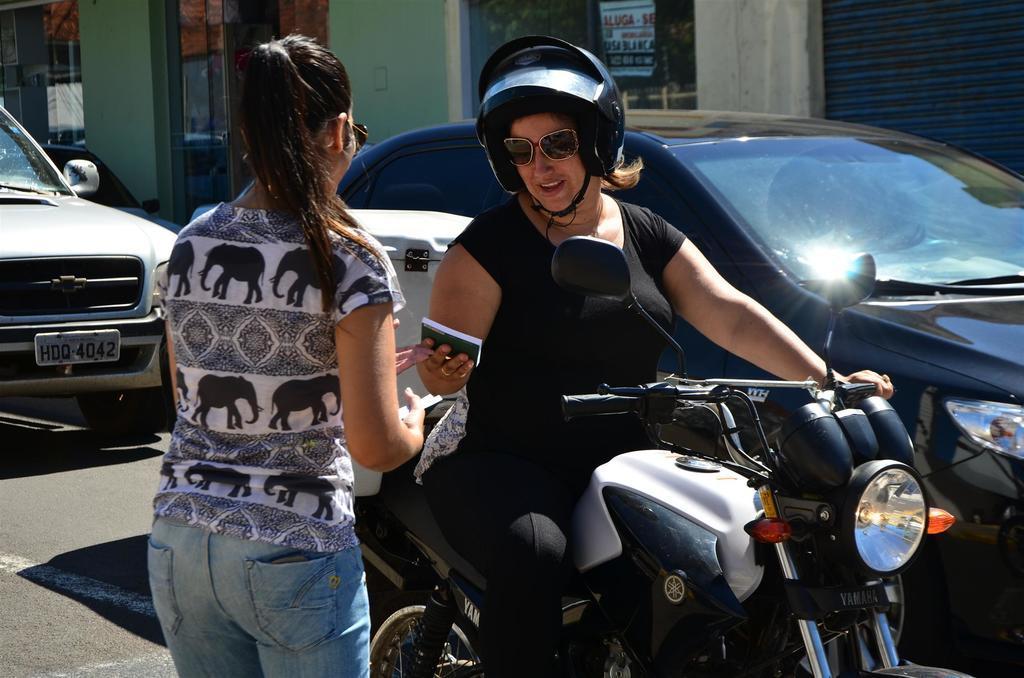Describe this image in one or two sentences. In the image we can see there are women who are in the image and a woman is sitting on bike and she is wearing a helmet and another woman is standing and at the back cars are parked on the road. 